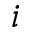<formula> <loc_0><loc_0><loc_500><loc_500>i</formula> 